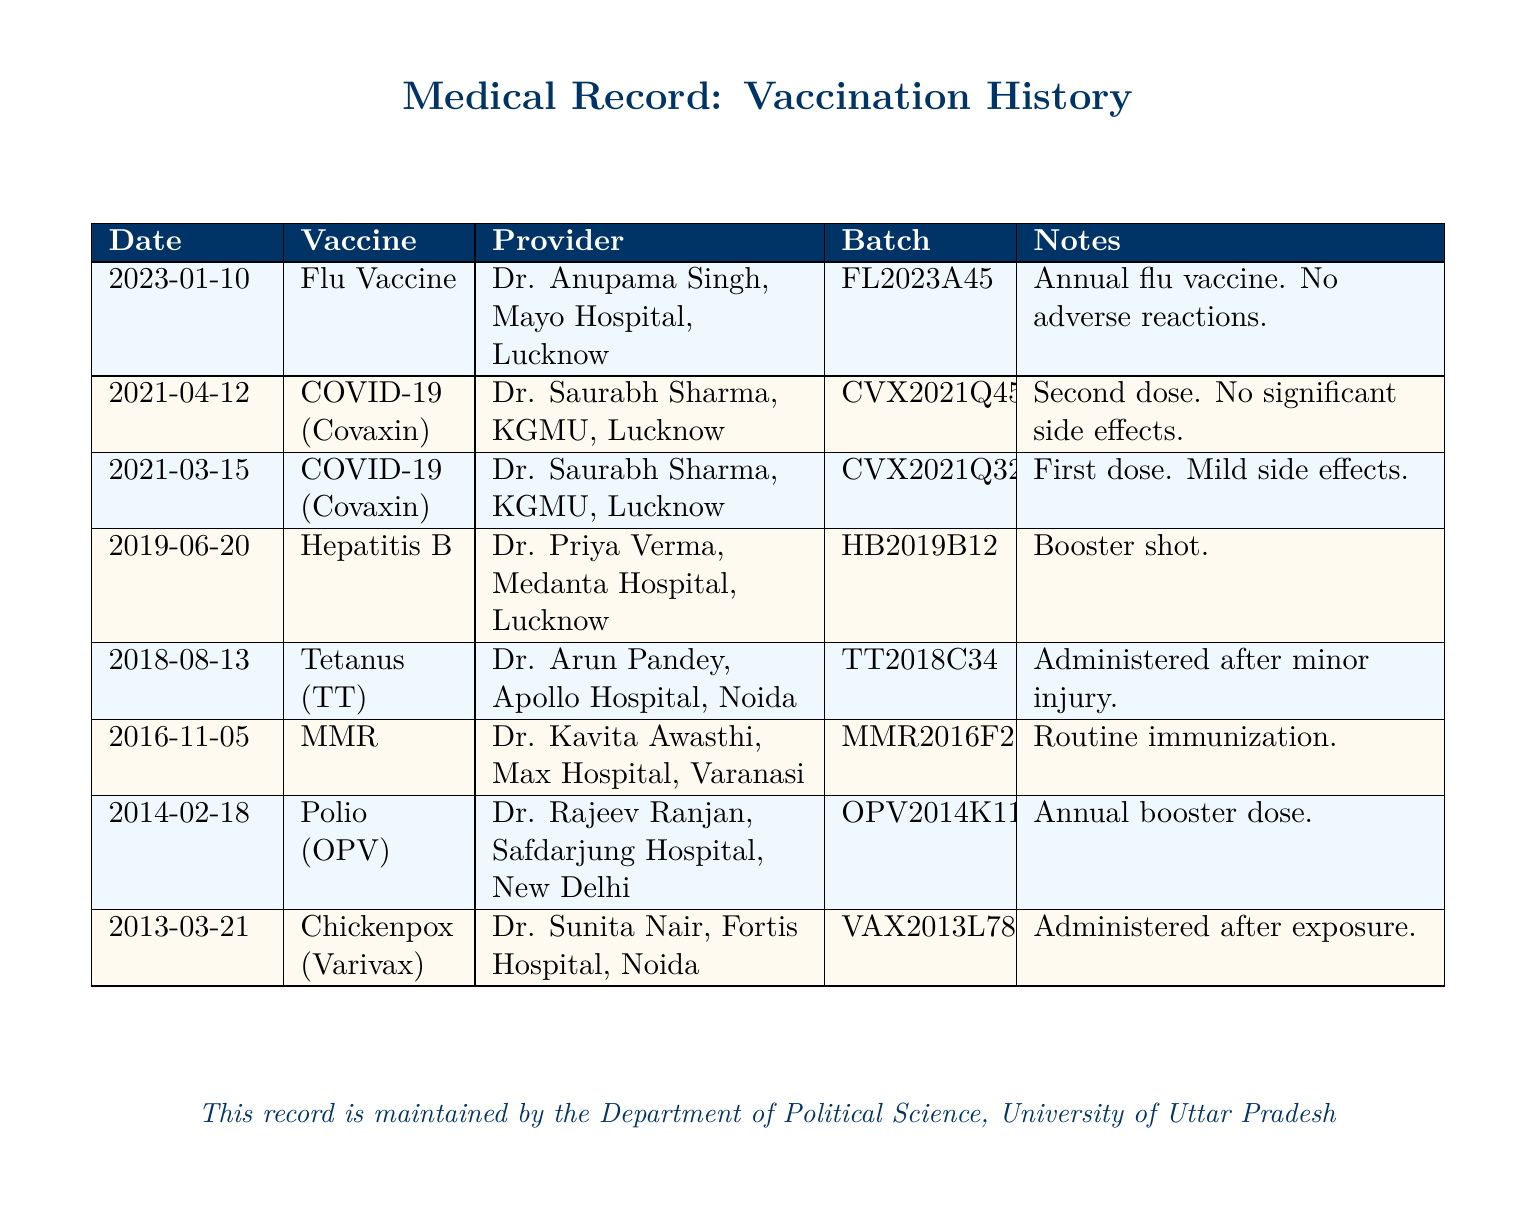What is the date of the last vaccination? The last vaccination recorded in the document was on January 10, 2023, which is the most recent entry.
Answer: 2023-01-10 Who administered the second dose of COVID-19 vaccine? The second dose of the COVID-19 vaccine was administered by Dr. Saurabh Sharma at KGMU in Lucknow, as per the records.
Answer: Dr. Saurabh Sharma What type of vaccine was administered on March 15, 2021? On March 15, 2021, the first dose of the COVID-19 vaccine (Covaxin) was administered, as specified in the document.
Answer: COVID-19 (Covaxin) How many vaccines were administered in 2019? The records show one vaccine administered in 2019, specifically the Hepatitis B booster shot.
Answer: 1 What is the batch number for the Flu Vaccine? The batch number for the Flu Vaccine administered on January 10, 2023, is FL2023A45, as noted in the vaccination history.
Answer: FL2023A45 What was the reason for administering the Tetanus vaccine? The Tetanus (TT) vaccine was administered after a minor injury, as indicated in the notes section of the record.
Answer: Administered after minor injury Which hospital provided the Polio vaccine? The Polio (OPV) vaccine was provided by Safdarjung Hospital in New Delhi, as detailed in the document.
Answer: Safdarjung Hospital, New Delhi What provider was involved on June 20, 2019? On June 20, 2019, the vaccine was administered by Dr. Priya Verma at Medanta Hospital in Lucknow.
Answer: Dr. Priya Verma How many doses of COVID-19 vaccine were given? According to the records, two doses of the COVID-19 vaccine (Covaxin) were administered.
Answer: 2 